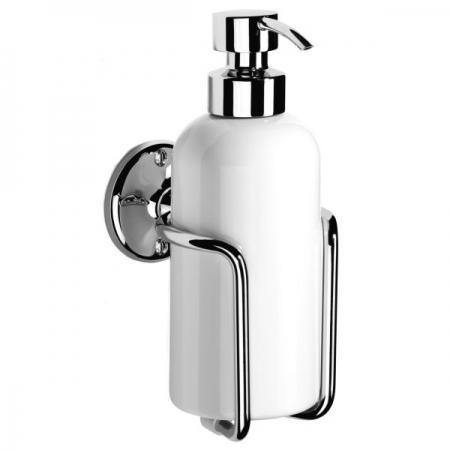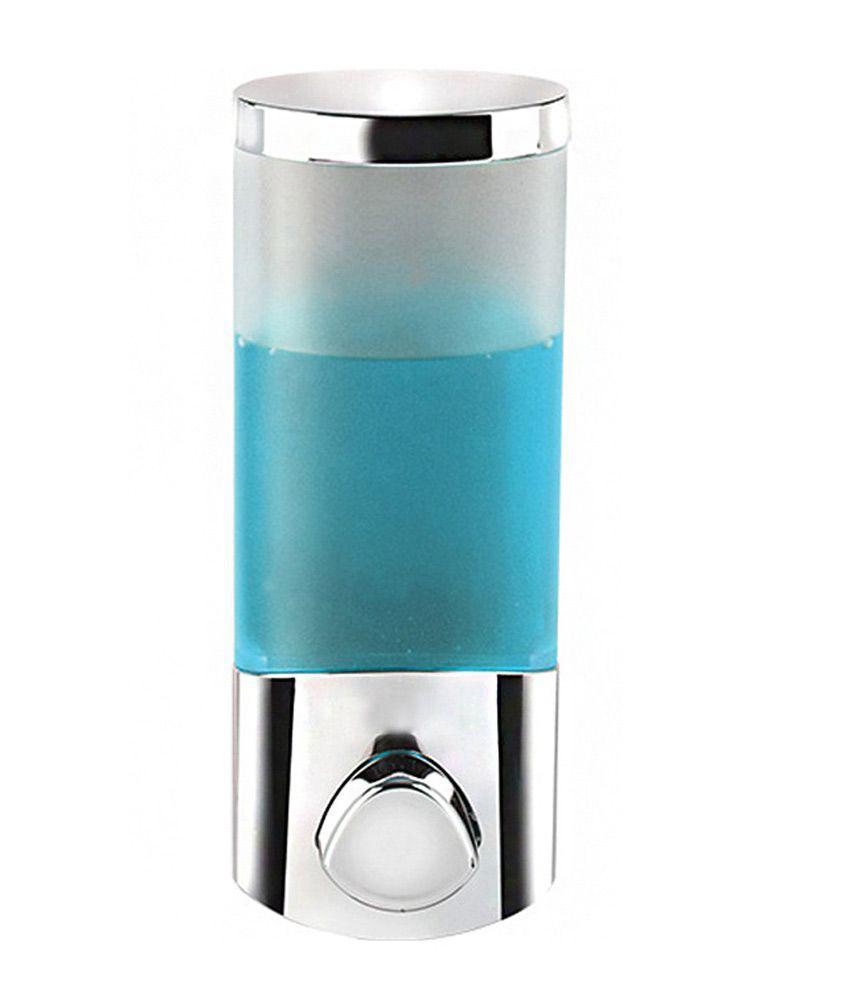The first image is the image on the left, the second image is the image on the right. Assess this claim about the two images: "One soap dispenser has a flat bottom and can be set on a counter.". Correct or not? Answer yes or no. Yes. 